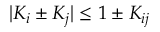<formula> <loc_0><loc_0><loc_500><loc_500>| K _ { i } \pm K _ { j } | \leq 1 \pm K _ { i j }</formula> 